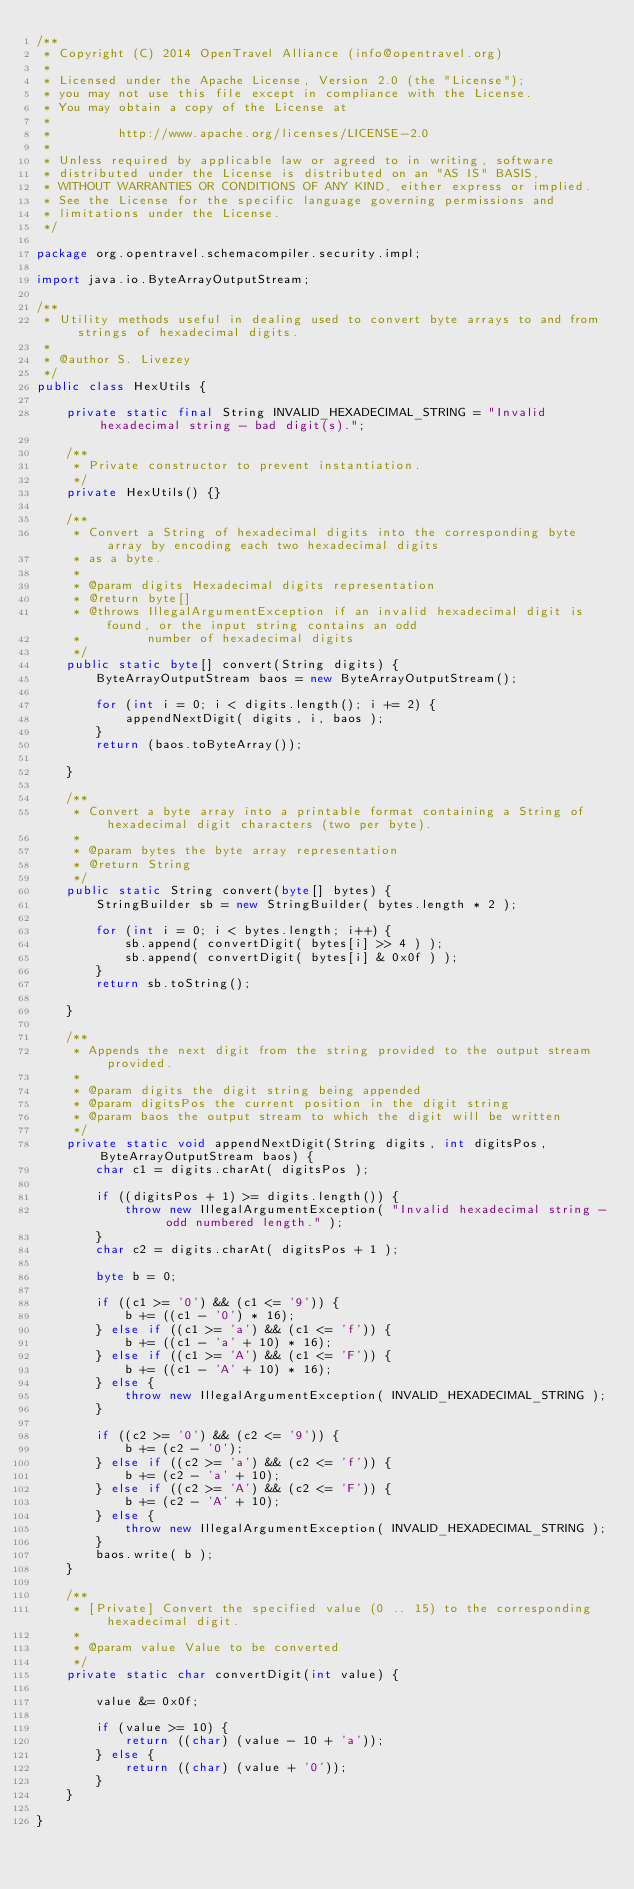<code> <loc_0><loc_0><loc_500><loc_500><_Java_>/**
 * Copyright (C) 2014 OpenTravel Alliance (info@opentravel.org)
 *
 * Licensed under the Apache License, Version 2.0 (the "License");
 * you may not use this file except in compliance with the License.
 * You may obtain a copy of the License at
 *
 *         http://www.apache.org/licenses/LICENSE-2.0
 *
 * Unless required by applicable law or agreed to in writing, software
 * distributed under the License is distributed on an "AS IS" BASIS,
 * WITHOUT WARRANTIES OR CONDITIONS OF ANY KIND, either express or implied.
 * See the License for the specific language governing permissions and
 * limitations under the License.
 */

package org.opentravel.schemacompiler.security.impl;

import java.io.ByteArrayOutputStream;

/**
 * Utility methods useful in dealing used to convert byte arrays to and from strings of hexadecimal digits.
 * 
 * @author S. Livezey
 */
public class HexUtils {

    private static final String INVALID_HEXADECIMAL_STRING = "Invalid hexadecimal string - bad digit(s).";

    /**
     * Private constructor to prevent instantiation.
     */
    private HexUtils() {}

    /**
     * Convert a String of hexadecimal digits into the corresponding byte array by encoding each two hexadecimal digits
     * as a byte.
     * 
     * @param digits Hexadecimal digits representation
     * @return byte[]
     * @throws IllegalArgumentException if an invalid hexadecimal digit is found, or the input string contains an odd
     *         number of hexadecimal digits
     */
    public static byte[] convert(String digits) {
        ByteArrayOutputStream baos = new ByteArrayOutputStream();

        for (int i = 0; i < digits.length(); i += 2) {
            appendNextDigit( digits, i, baos );
        }
        return (baos.toByteArray());

    }

    /**
     * Convert a byte array into a printable format containing a String of hexadecimal digit characters (two per byte).
     * 
     * @param bytes the byte array representation
     * @return String
     */
    public static String convert(byte[] bytes) {
        StringBuilder sb = new StringBuilder( bytes.length * 2 );

        for (int i = 0; i < bytes.length; i++) {
            sb.append( convertDigit( bytes[i] >> 4 ) );
            sb.append( convertDigit( bytes[i] & 0x0f ) );
        }
        return sb.toString();

    }

    /**
     * Appends the next digit from the string provided to the output stream provided.
     * 
     * @param digits the digit string being appended
     * @param digitsPos the current position in the digit string
     * @param baos the output stream to which the digit will be written
     */
    private static void appendNextDigit(String digits, int digitsPos, ByteArrayOutputStream baos) {
        char c1 = digits.charAt( digitsPos );

        if ((digitsPos + 1) >= digits.length()) {
            throw new IllegalArgumentException( "Invalid hexadecimal string - odd numbered length." );
        }
        char c2 = digits.charAt( digitsPos + 1 );

        byte b = 0;

        if ((c1 >= '0') && (c1 <= '9')) {
            b += ((c1 - '0') * 16);
        } else if ((c1 >= 'a') && (c1 <= 'f')) {
            b += ((c1 - 'a' + 10) * 16);
        } else if ((c1 >= 'A') && (c1 <= 'F')) {
            b += ((c1 - 'A' + 10) * 16);
        } else {
            throw new IllegalArgumentException( INVALID_HEXADECIMAL_STRING );
        }

        if ((c2 >= '0') && (c2 <= '9')) {
            b += (c2 - '0');
        } else if ((c2 >= 'a') && (c2 <= 'f')) {
            b += (c2 - 'a' + 10);
        } else if ((c2 >= 'A') && (c2 <= 'F')) {
            b += (c2 - 'A' + 10);
        } else {
            throw new IllegalArgumentException( INVALID_HEXADECIMAL_STRING );
        }
        baos.write( b );
    }

    /**
     * [Private] Convert the specified value (0 .. 15) to the corresponding hexadecimal digit.
     * 
     * @param value Value to be converted
     */
    private static char convertDigit(int value) {

        value &= 0x0f;

        if (value >= 10) {
            return ((char) (value - 10 + 'a'));
        } else {
            return ((char) (value + '0'));
        }
    }

}
</code> 